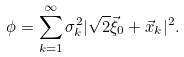Convert formula to latex. <formula><loc_0><loc_0><loc_500><loc_500>\phi = \sum _ { k = 1 } ^ { \infty } \sigma _ { k } ^ { 2 } | \sqrt { 2 } \vec { \xi } _ { 0 } + \vec { x } _ { k } | ^ { 2 } .</formula> 